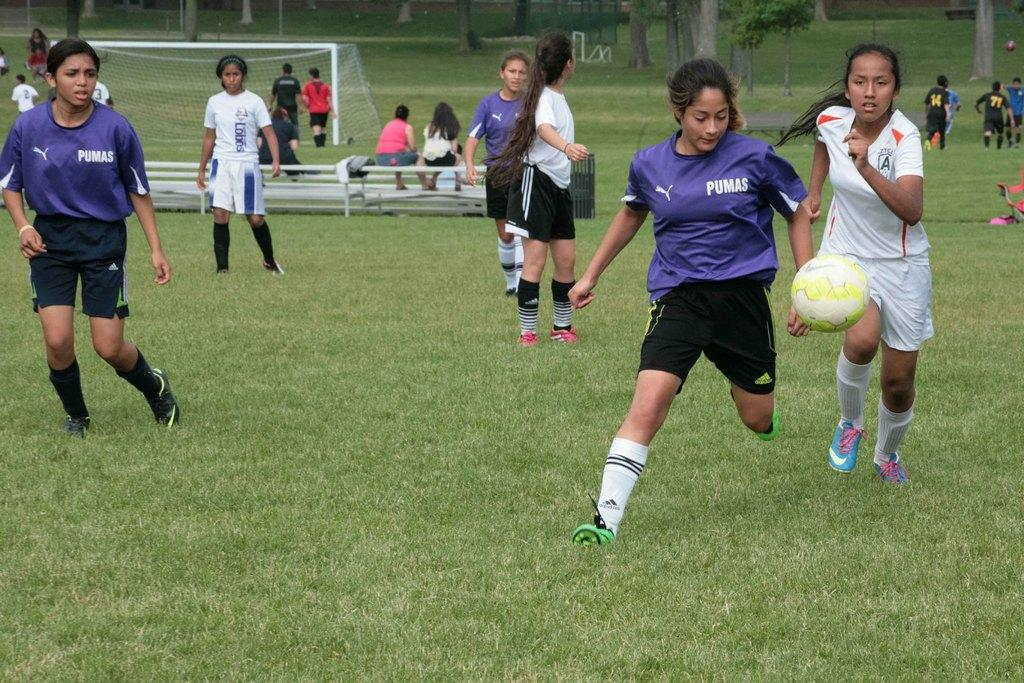<image>
Give a short and clear explanation of the subsequent image. soccer players for the Pumas and Lobos compete on a field 